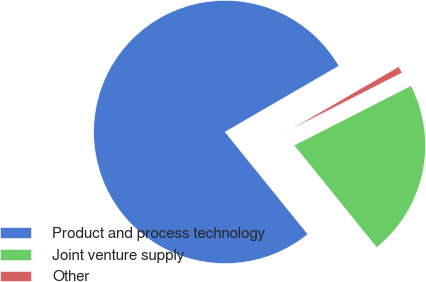Convert chart to OTSL. <chart><loc_0><loc_0><loc_500><loc_500><pie_chart><fcel>Product and process technology<fcel>Joint venture supply<fcel>Other<nl><fcel>77.46%<fcel>21.68%<fcel>0.86%<nl></chart> 